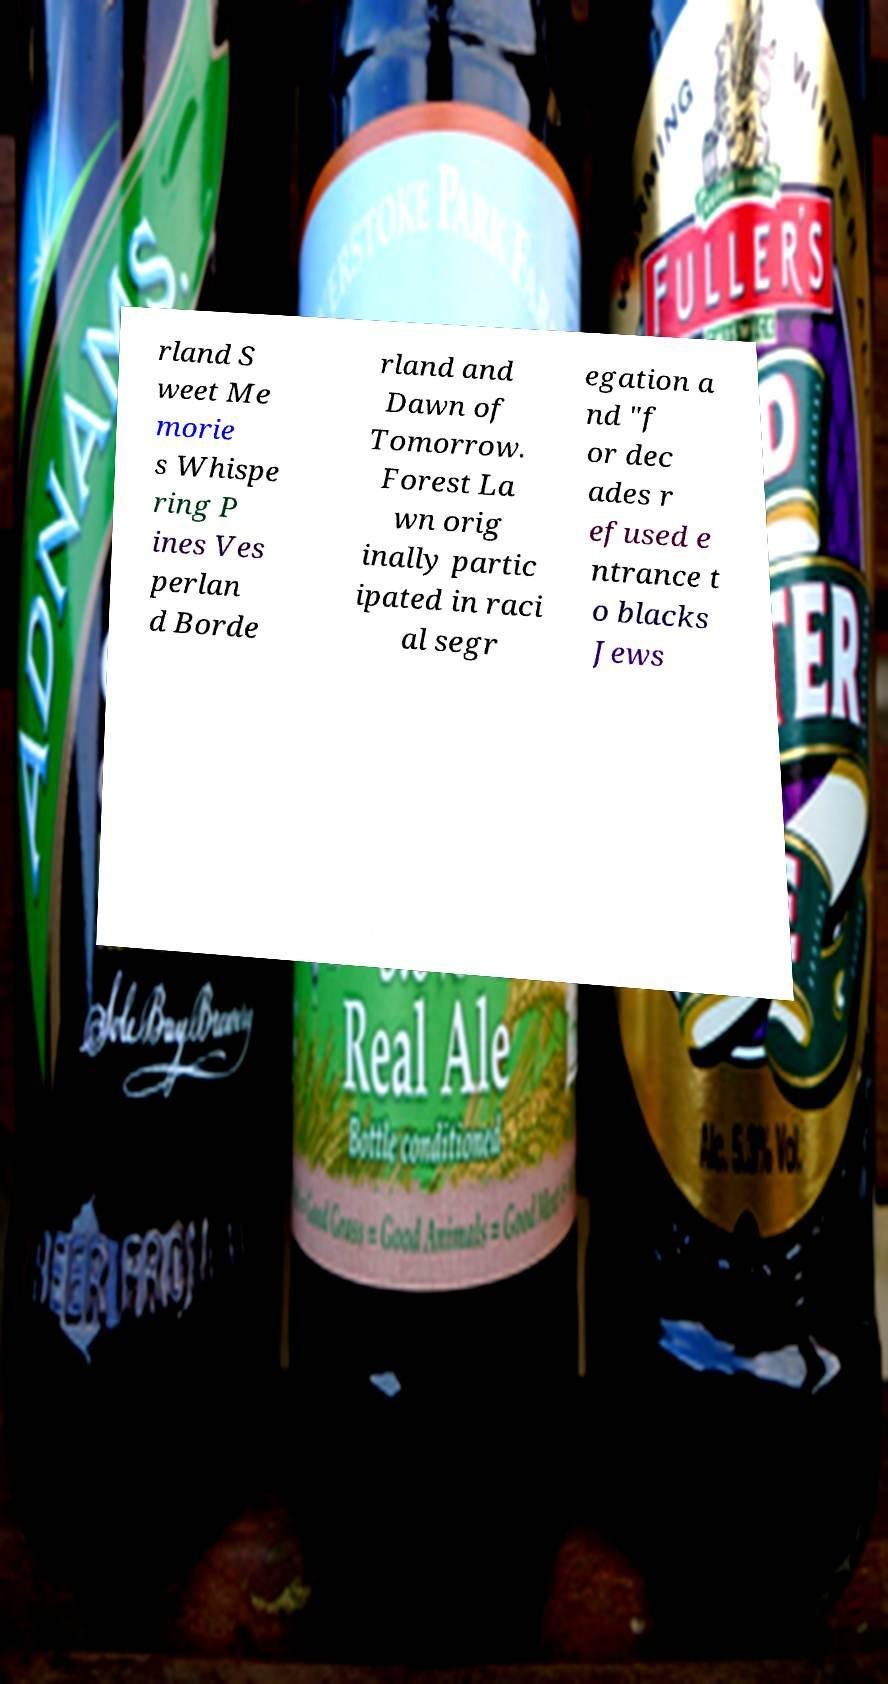Can you accurately transcribe the text from the provided image for me? rland S weet Me morie s Whispe ring P ines Ves perlan d Borde rland and Dawn of Tomorrow. Forest La wn orig inally partic ipated in raci al segr egation a nd "f or dec ades r efused e ntrance t o blacks Jews 